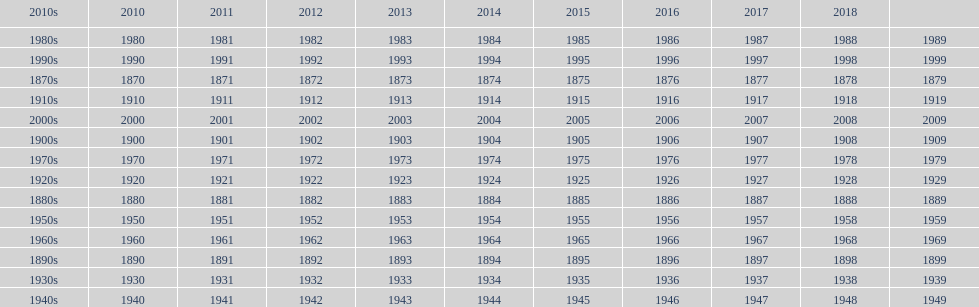Mathematically speaking, what is the difference between 2015 and 1912? 103. 